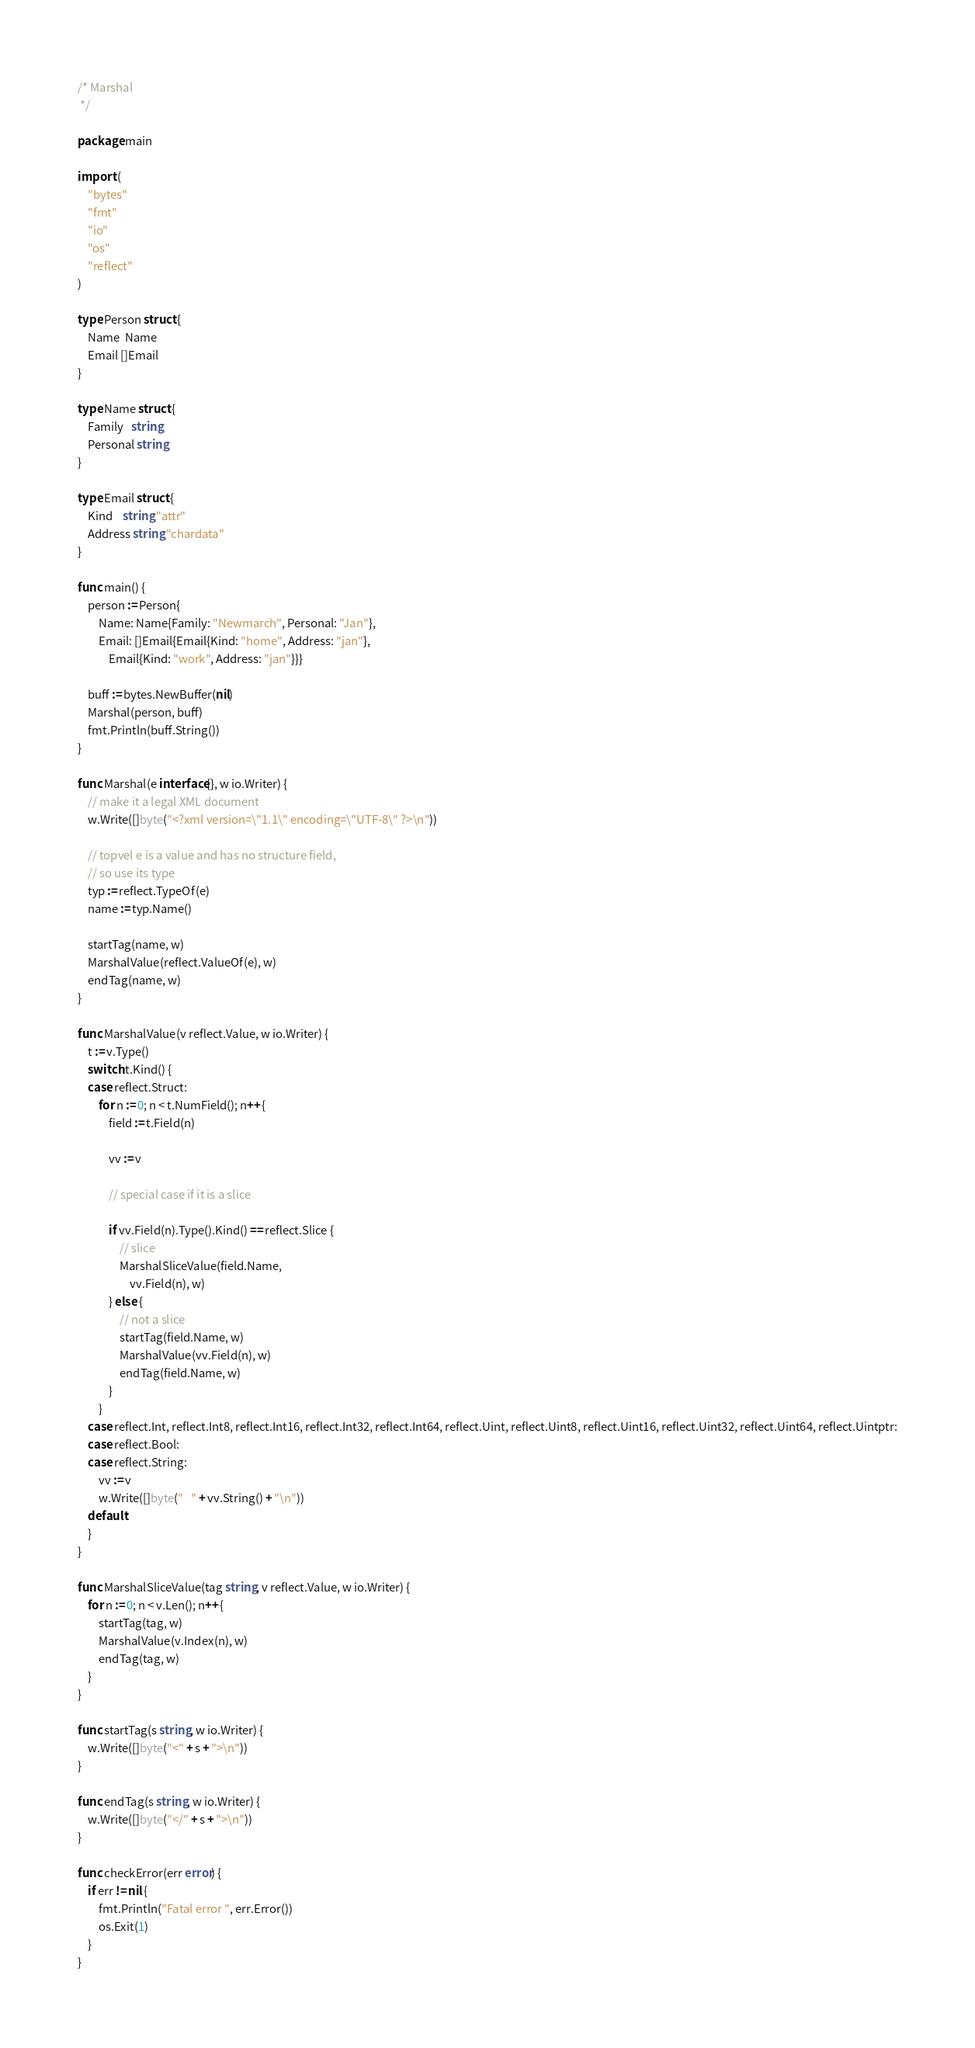Convert code to text. <code><loc_0><loc_0><loc_500><loc_500><_Go_>/* Marshal
 */

package main

import (
	"bytes"
	"fmt"
	"io"
	"os"
	"reflect"
)

type Person struct {
	Name  Name
	Email []Email
}

type Name struct {
	Family   string
	Personal string
}

type Email struct {
	Kind    string "attr"
	Address string "chardata"
}

func main() {
	person := Person{
		Name: Name{Family: "Newmarch", Personal: "Jan"},
		Email: []Email{Email{Kind: "home", Address: "jan"},
			Email{Kind: "work", Address: "jan"}}}

	buff := bytes.NewBuffer(nil)
	Marshal(person, buff)
	fmt.Println(buff.String())
}

func Marshal(e interface{}, w io.Writer) {
	// make it a legal XML document
	w.Write([]byte("<?xml version=\"1.1\" encoding=\"UTF-8\" ?>\n"))

	// topvel e is a value and has no structure field,
	// so use its type
	typ := reflect.TypeOf(e)
	name := typ.Name()

	startTag(name, w)
	MarshalValue(reflect.ValueOf(e), w)
	endTag(name, w)
}

func MarshalValue(v reflect.Value, w io.Writer) {
	t := v.Type()
	switch t.Kind() {
	case reflect.Struct:
		for n := 0; n < t.NumField(); n++ {
			field := t.Field(n)

			vv := v

			// special case if it is a slice

			if vv.Field(n).Type().Kind() == reflect.Slice {
				// slice
				MarshalSliceValue(field.Name,
					vv.Field(n), w)
			} else {
				// not a slice
				startTag(field.Name, w)
				MarshalValue(vv.Field(n), w)
				endTag(field.Name, w)
			}
		}
	case reflect.Int, reflect.Int8, reflect.Int16, reflect.Int32, reflect.Int64, reflect.Uint, reflect.Uint8, reflect.Uint16, reflect.Uint32, reflect.Uint64, reflect.Uintptr:
	case reflect.Bool:
	case reflect.String:
		vv := v
		w.Write([]byte("   " + vv.String() + "\n"))
	default:
	}
}

func MarshalSliceValue(tag string, v reflect.Value, w io.Writer) {
	for n := 0; n < v.Len(); n++ {
		startTag(tag, w)
		MarshalValue(v.Index(n), w)
		endTag(tag, w)
	}
}

func startTag(s string, w io.Writer) {
	w.Write([]byte("<" + s + ">\n"))
}

func endTag(s string, w io.Writer) {
	w.Write([]byte("</" + s + ">\n"))
}

func checkError(err error) {
	if err != nil {
		fmt.Println("Fatal error ", err.Error())
		os.Exit(1)
	}
}
</code> 